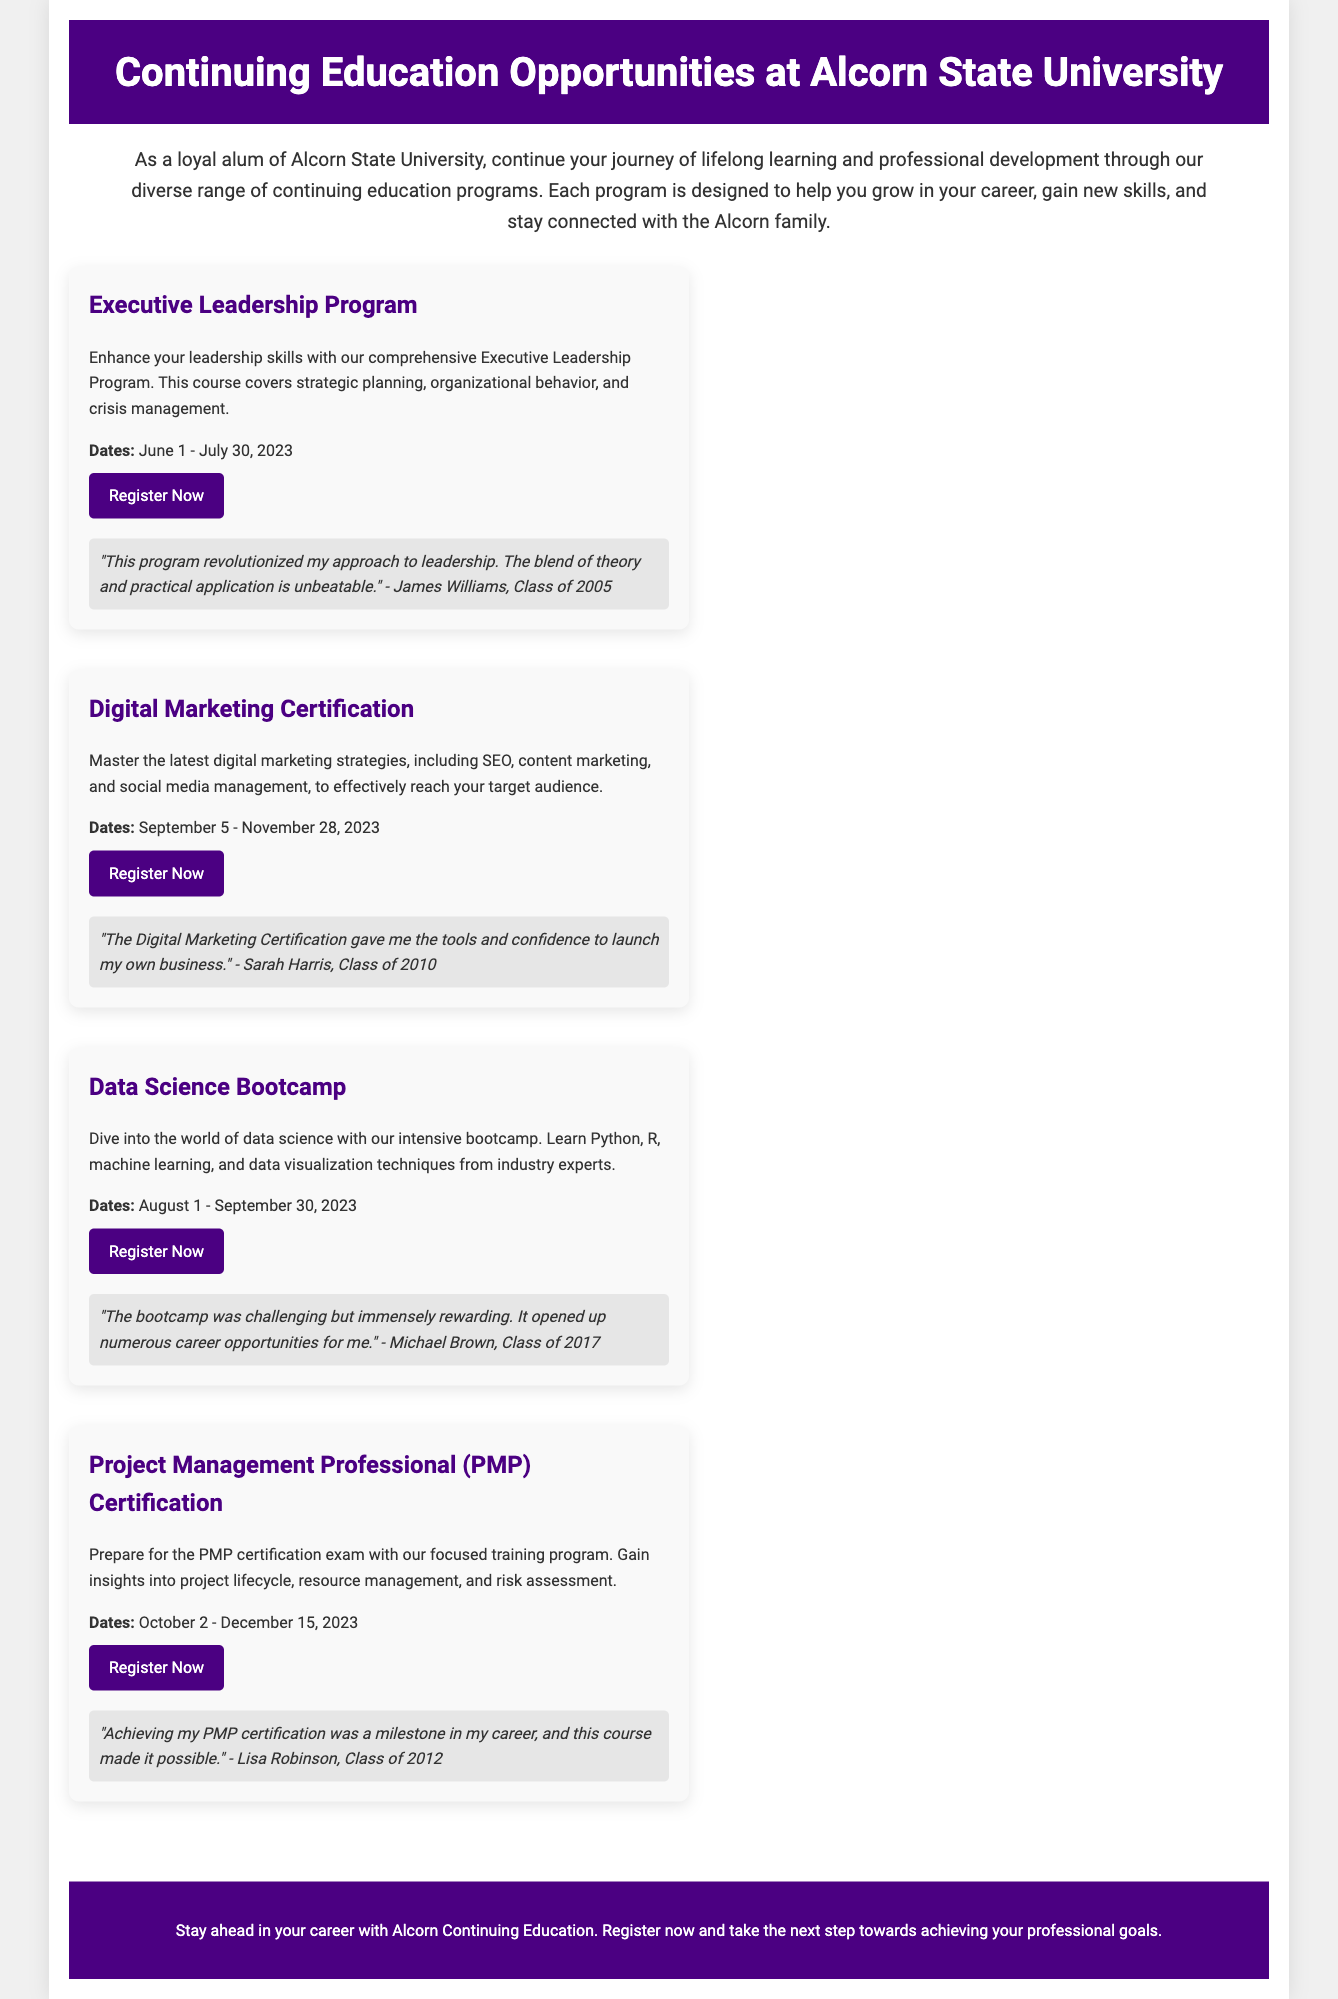What is the title of the document? The title of the document is stated in the header section.
Answer: Continuing Education Opportunities at Alcorn State University How many continuing education programs are listed? The number of programs is indicated by the number of program sections present in the document.
Answer: 4 What is the date range for the Digital Marketing Certification? The date range for the course is specified in the program description.
Answer: September 5 - November 28, 2023 Who provided a testimonial for the Executive Leadership Program? The testimonial section of the program includes the name of a past participant.
Answer: James Williams What is the focus of the Data Science Bootcamp? The program description outlines the key topics covered in the bootcamp.
Answer: Python, R, machine learning, and data visualization techniques When does the Project Management Professional certification preparation start? The beginning date of the course is found in the dates section of the program description.
Answer: October 2, 2023 Which program emphasizes digital marketing strategies? The program title indicates which course is focused on digital marketing.
Answer: Digital Marketing Certification What background color is used for the footer? The footer color is described in the styling section of the document.
Answer: #4B0082 